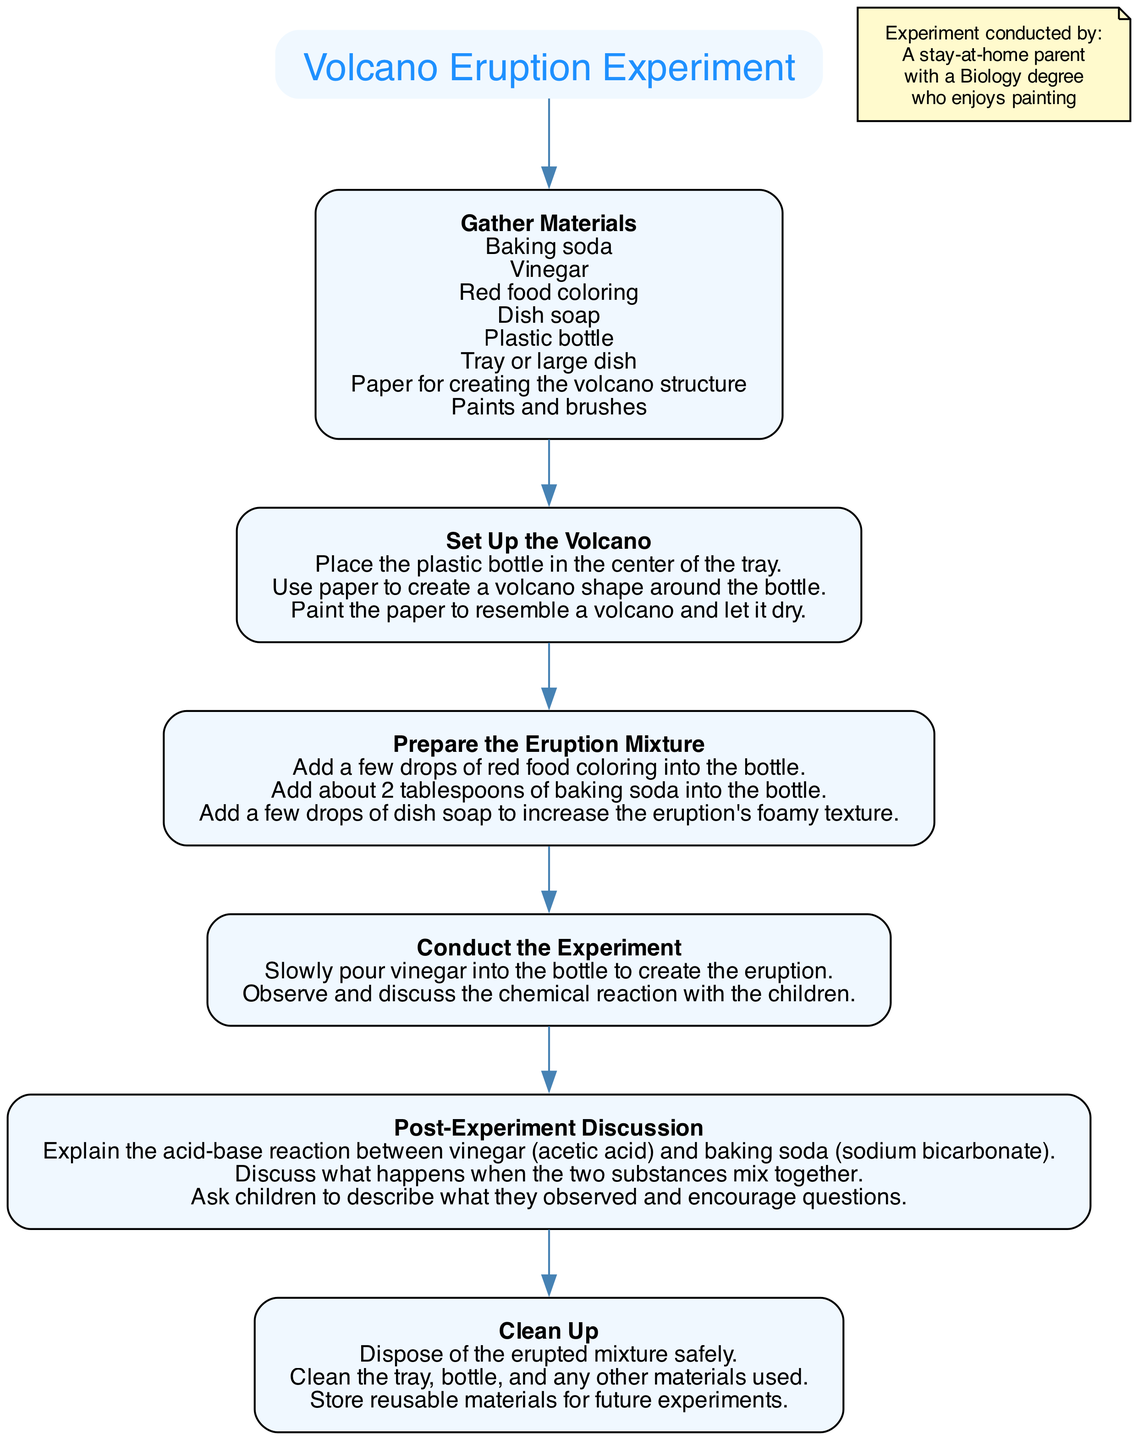What is the title of the experiment? The title of the experiment is found at the top of the diagram, labeled clearly before the steps, which is "Volcano Eruption Experiment."
Answer: Volcano Eruption Experiment How many steps are there in the diagram? By counting the individual steps listed in the flow chart, we see there are a total of six clear instructional steps outlined in the process.
Answer: 6 What materials are needed for the experiment? The first step clearly outlines the materials required for the experiment; they are stated in the list under the "Gather Materials" step. They include baking soda, vinegar, red food coloring, dish soap, a plastic bottle, a tray or large dish, paper, paints, and brushes.
Answer: Baking soda, vinegar, red food coloring, dish soap, plastic bottle, tray or large dish, paper, paints, brushes What is the next step after "Set Up the Volcano"? We follow the directional flow from the "Set Up the Volcano" step, which leads directly to the next step, "Prepare the Eruption Mixture."
Answer: Prepare the Eruption Mixture What is the purpose of the "Post-Experiment Discussion" step? This step focuses on explaining the chemical reaction of the experiment, encouraging children to understand and discuss their observations, which elaborates on the learning aspect of the activity.
Answer: Explain the acid-base reaction What do you add to the bottle first in the "Prepare the Eruption Mixture"? The instructions specify that the first action in preparing the eruption mixture is to add a few drops of red food coloring into the bottle.
Answer: A few drops of red food coloring What should be done immediately after the eruption occurs? Immediately after the eruption, the diagram instructs to "Observe and discuss the chemical reaction with the children,” which emphasizes the importance of active engagement following the experiment.
Answer: Observe and discuss What should be done with the erupted mixture during cleanup? The cleanup step explicitly states that the erupted mixture should be "disposed of safely," indicating a clear action that needs to be completed for safety reasons.
Answer: Dispose of the erupted mixture safely 